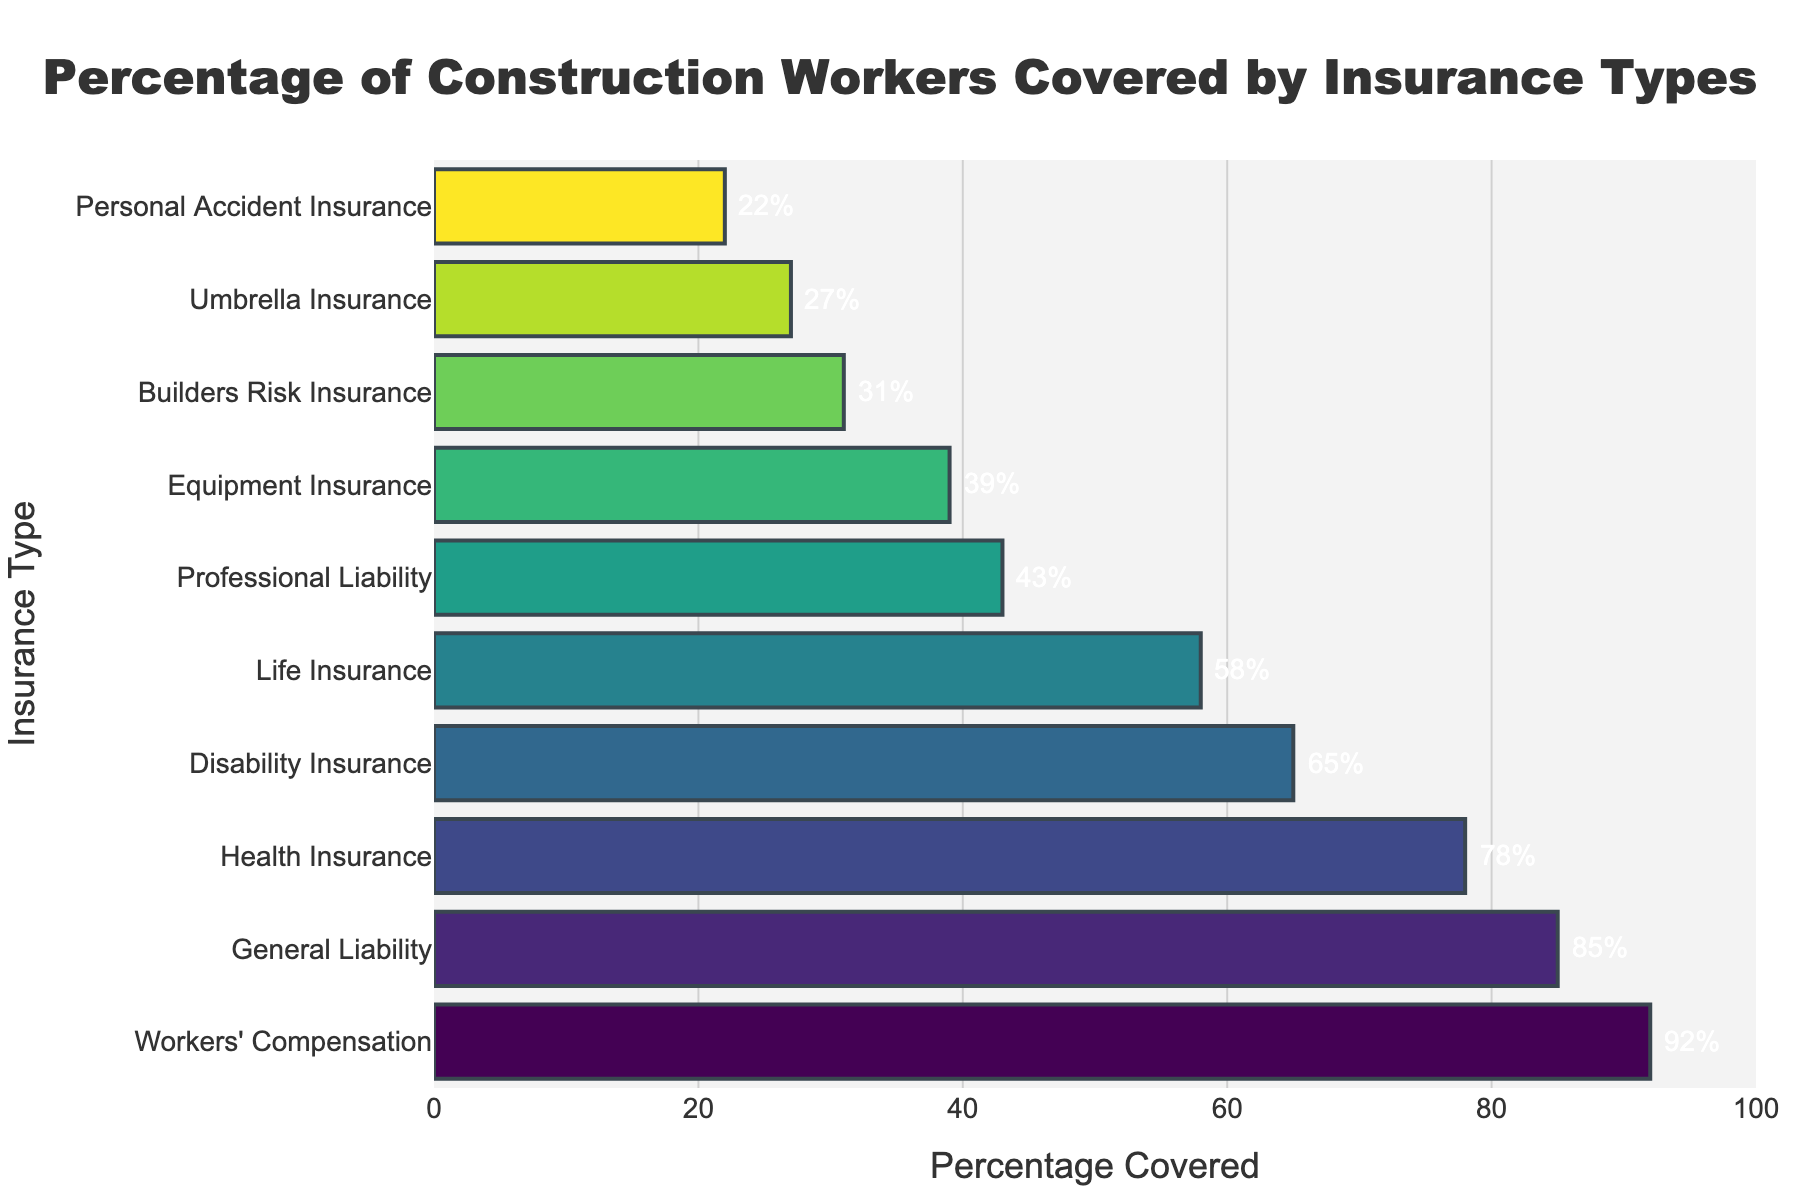What type of insurance has the highest coverage among construction workers? The figure shows that Workers' Compensation has the highest bar, indicating it has the highest percentage of coverage among construction workers.
Answer: Workers' Compensation How much higher is the coverage for General Liability insurance compared to Professional Liability insurance? General Liability insurance has a coverage of 85%, while Professional Liability insurance has 43%. Subtracting these two values, 85% - 43% = 42%.
Answer: 42% Which insurance type has the lowest coverage percentage? The figure's bar representing Personal Accident Insurance is the shortest, indicating it has the lowest coverage percentage at 22%.
Answer: Personal Accident Insurance Combine the coverage percentages for Disability Insurance and Equipment Insurance. What is their total? Disability Insurance has a coverage of 65%, and Equipment Insurance has 39%. Adding them together, 65% + 39% = 104%.
Answer: 104% Between Health Insurance and Life Insurance, which has a higher percentage of coverage, and by how much? Health Insurance has a coverage of 78%, while Life Insurance has 58%. The difference is 78% - 58% = 20%.
Answer: Health Insurance, 20% What is the mean coverage percentage for the first five types of insurance listed? The first five types listed are Workers' Compensation (92%), General Liability (85%), Health Insurance (78%), Disability Insurance (65%), and Life Insurance (58%). The mean is calculated by (92 + 85 + 78 + 65 + 58) / 5 = 378 / 5 = 75.6%.
Answer: 75.6% What percentage of construction workers are not covered by Builders Risk Insurance? Builders Risk Insurance has a coverage of 31%. The percentage not covered is 100% - 31% = 69%.
Answer: 69% Which two insurance types are closest in terms of coverage percentage, and what are their percentages? Life Insurance (58%) and Disability Insurance (65%) have the coverage percentages closer to each other. The difference is
Answer: Life Insurance (58%) and Disability Insurance (65%) How many insurance types have a coverage percentage above 50%? Counting the bars in the figure, Workers' Compensation, General Liability, Health Insurance, Disability Insurance, and Life Insurance have percentages above 50%.
Answer: 5 types What is the combined coverage percentage of all insurance types listed? Sum up all the percentages: 92 + 85 + 78 + 65 + 58 + 43 + 39 + 31 + 27 + 22 = 540%.
Answer: 540% 